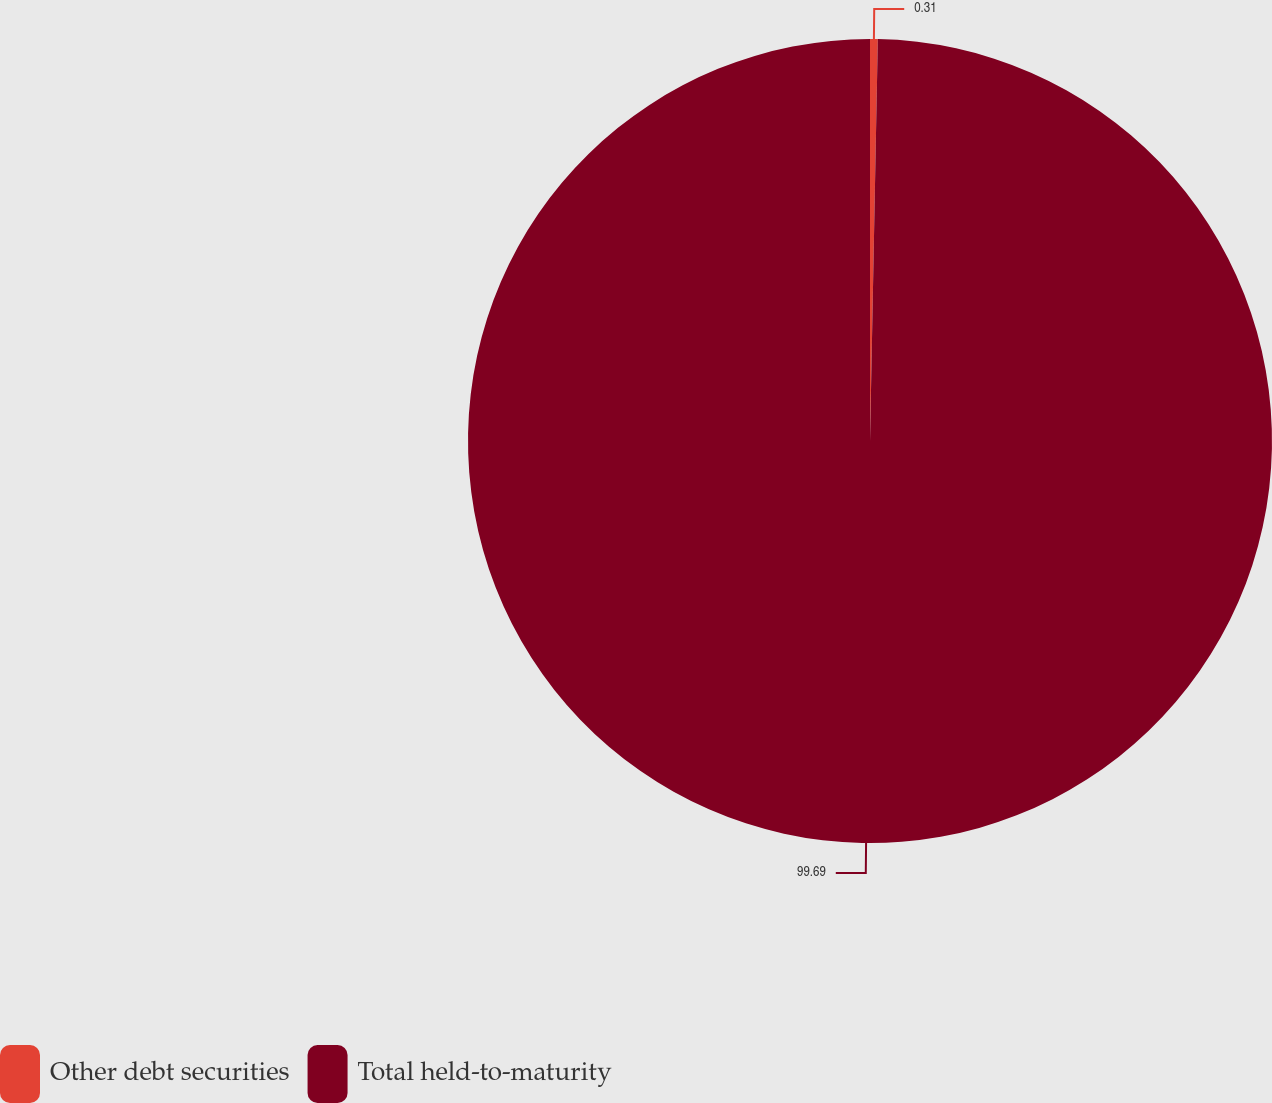<chart> <loc_0><loc_0><loc_500><loc_500><pie_chart><fcel>Other debt securities<fcel>Total held-to-maturity<nl><fcel>0.31%<fcel>99.69%<nl></chart> 